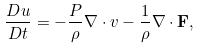Convert formula to latex. <formula><loc_0><loc_0><loc_500><loc_500>\frac { D u } { D t } = - \frac { P } { \rho } \nabla \cdot v - \frac { 1 } { \rho } \nabla \cdot \mathbf F ,</formula> 